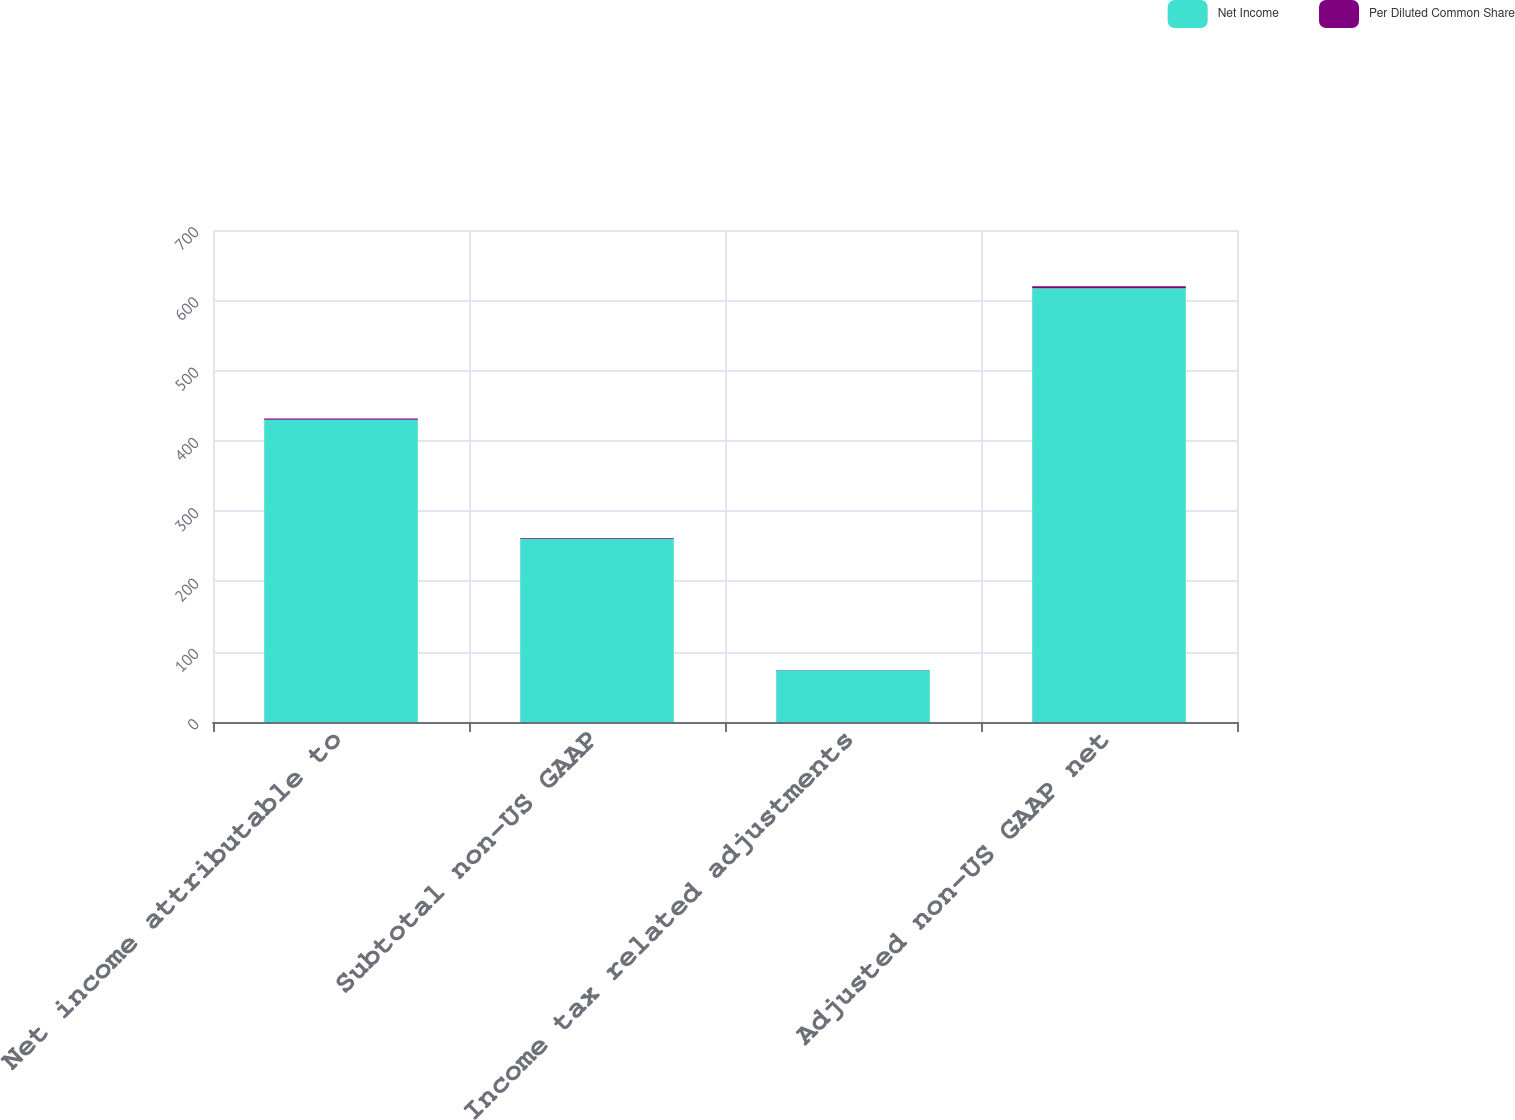Convert chart. <chart><loc_0><loc_0><loc_500><loc_500><stacked_bar_chart><ecel><fcel>Net income attributable to<fcel>Subtotal non-US GAAP<fcel>Income tax related adjustments<fcel>Adjusted non-US GAAP net<nl><fcel>Net Income<fcel>429.9<fcel>260.7<fcel>73.5<fcel>617.1<nl><fcel>Per Diluted Common Share<fcel>1.94<fcel>1.17<fcel>0.33<fcel>2.78<nl></chart> 